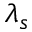<formula> <loc_0><loc_0><loc_500><loc_500>\lambda _ { s }</formula> 